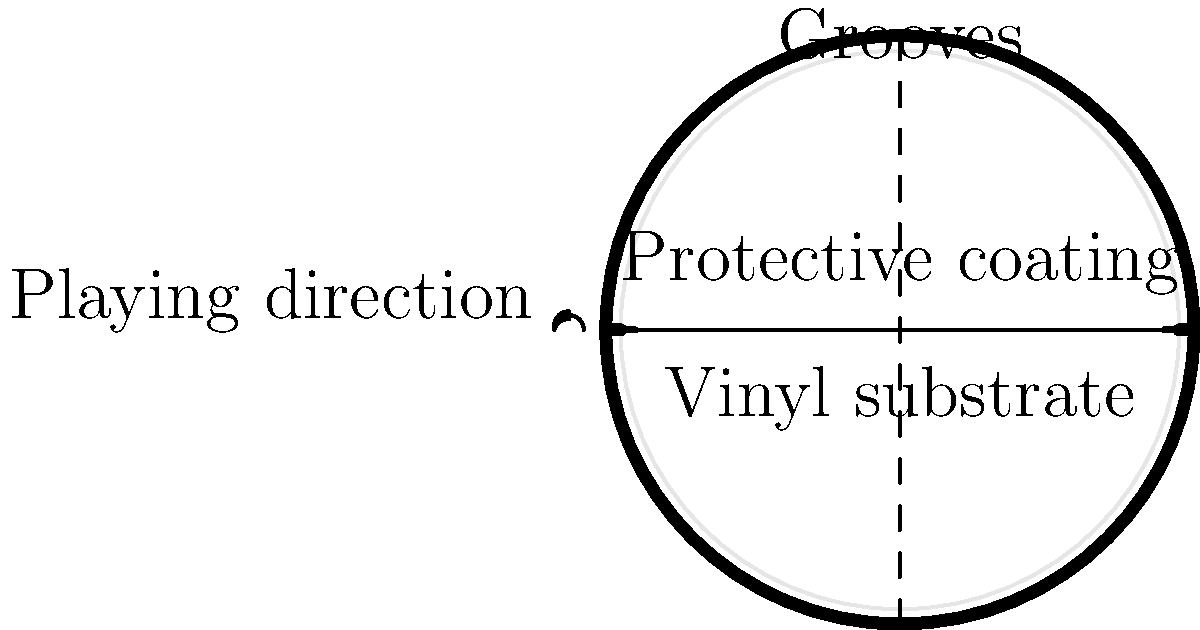In the cross-section of a vinyl record shown above, what is the purpose of the thin layer on top of the vinyl substrate? To understand the purpose of the thin layer on top of the vinyl substrate, let's break down the structure of a vinyl record:

1. The main body of the record is made of vinyl, which forms the substrate. This is the thickest layer and provides the structural integrity of the record.

2. On top of the vinyl substrate, there is a thin layer. This layer is crucial for the record's function and longevity.

3. The thin layer serves as a protective coating. Its primary purposes are:
   a) To protect the grooves from dust and debris
   b) To reduce wear and tear from the stylus (needle) as it moves through the grooves
   c) To enhance the overall durability of the record

4. This protective layer is typically made of a material that is harder than the vinyl substrate, which helps to preserve the intricate groove patterns that contain the audio information.

5. Without this protective layer, the grooves would be more susceptible to damage from repeated plays, handling, and environmental factors, potentially degrading the sound quality over time.

6. For a 70's folk music enthusiast who values original album track order, this protective layer is essential in maintaining the integrity of the record's sound and ensuring that the music can be enjoyed as intended by the artists for many years.
Answer: Protective coating 